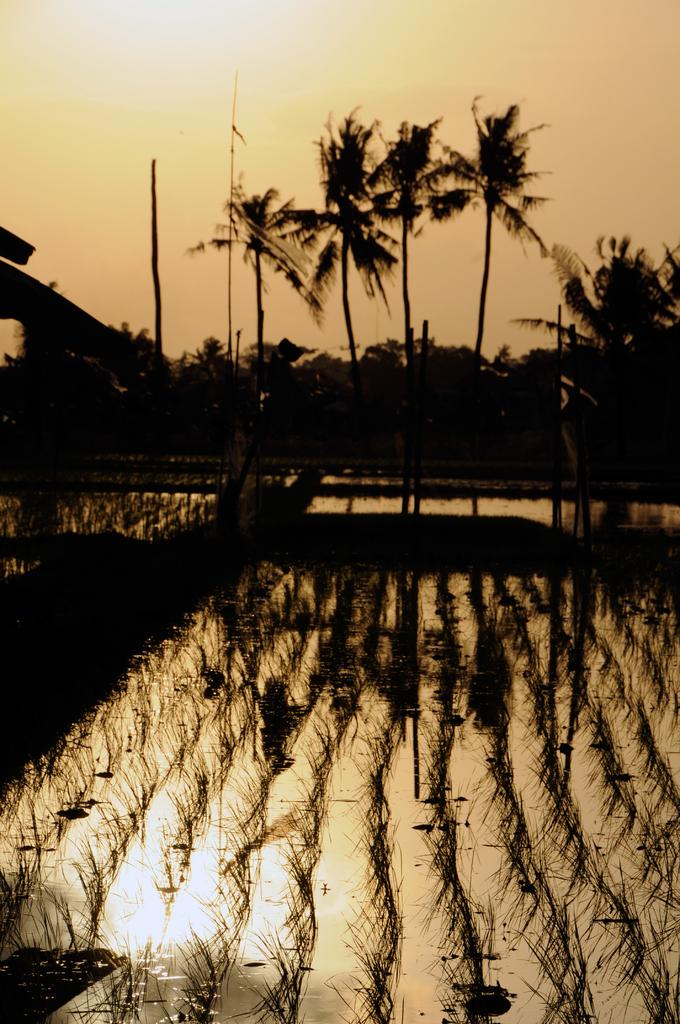What is the primary element visible in the image? There is water in the image. What type of vegetation can be seen in the image? There is a group of plants in the image. What can be seen in the background of the image? There is a group of trees and the sky visible in the background of the image. Can you tell me how many glasses are on the table in the image? There is no table or glass present in the image; it primarily features water, plants, trees, and the sky. 